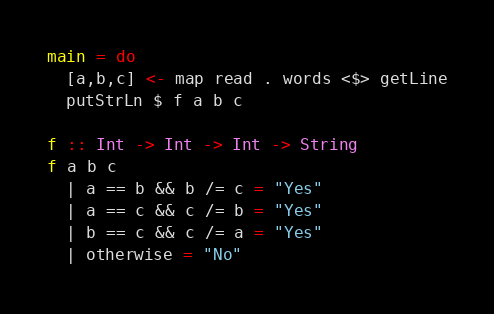Convert code to text. <code><loc_0><loc_0><loc_500><loc_500><_Haskell_>main = do
  [a,b,c] <- map read . words <$> getLine
  putStrLn $ f a b c

f :: Int -> Int -> Int -> String
f a b c 
  | a == b && b /= c = "Yes"
  | a == c && c /= b = "Yes"
  | b == c && c /= a = "Yes"
  | otherwise = "No"</code> 